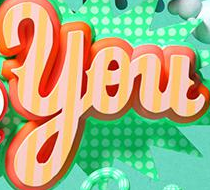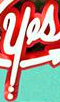Read the text content from these images in order, separated by a semicolon. You; yes 